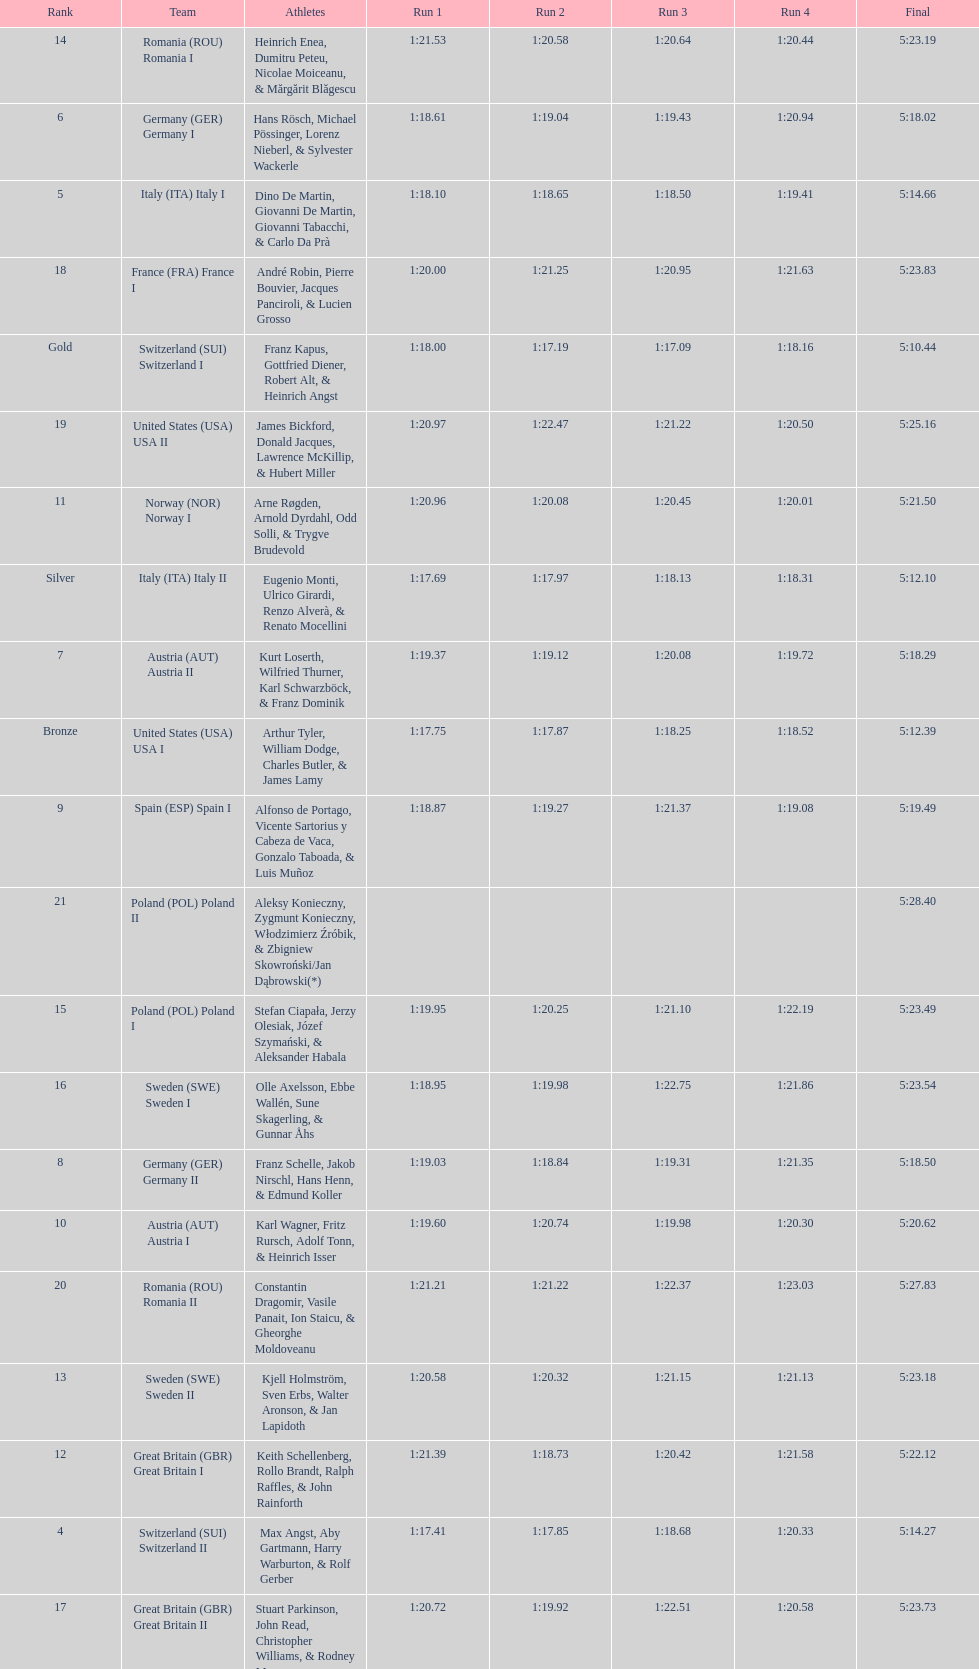Name a country that had 4 consecutive runs under 1:19. Switzerland. 